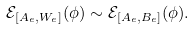Convert formula to latex. <formula><loc_0><loc_0><loc_500><loc_500>\mathcal { E } _ { [ A _ { e } , W _ { e } ] } ( \phi ) \sim \mathcal { E } _ { [ A _ { e } , B _ { e } ] } ( \phi ) .</formula> 